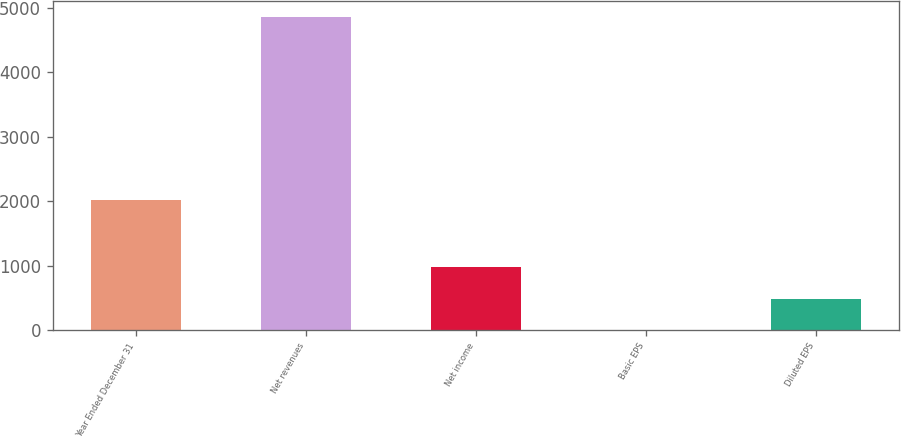Convert chart to OTSL. <chart><loc_0><loc_0><loc_500><loc_500><bar_chart><fcel>Year Ended December 31<fcel>Net revenues<fcel>Net income<fcel>Basic EPS<fcel>Diluted EPS<nl><fcel>2011<fcel>4857<fcel>971.97<fcel>0.71<fcel>486.34<nl></chart> 